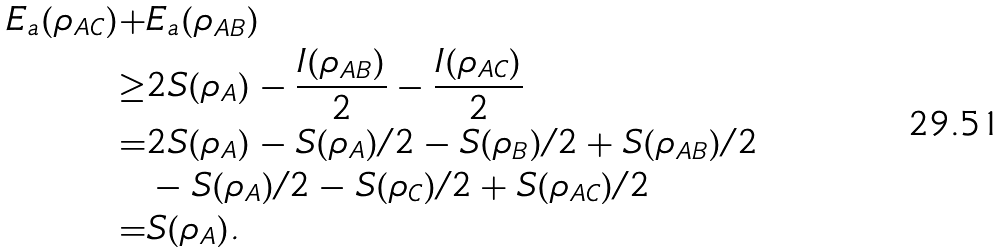<formula> <loc_0><loc_0><loc_500><loc_500>E _ { a } ( \rho _ { A C } ) + & E _ { a } ( \rho _ { A B } ) \\ \geq & 2 S ( \rho _ { A } ) - \frac { I ( \rho _ { A B } ) } { 2 } - \frac { I ( \rho _ { A C } ) } { 2 } \\ = & 2 S ( \rho _ { A } ) - S ( \rho _ { A } ) / 2 - S ( \rho _ { B } ) / 2 + S ( \rho _ { A B } ) / 2 \\ & - S ( \rho _ { A } ) / 2 - S ( \rho _ { C } ) / 2 + S ( \rho _ { A C } ) / 2 \\ = & S ( \rho _ { A } ) .</formula> 